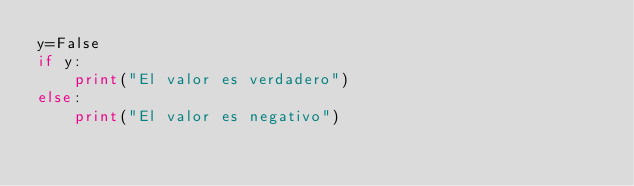Convert code to text. <code><loc_0><loc_0><loc_500><loc_500><_Python_>y=False
if y:
    print("El valor es verdadero")
else:
    print("El valor es negativo")</code> 